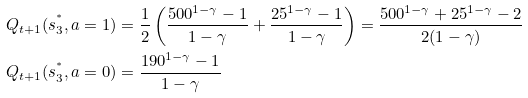<formula> <loc_0><loc_0><loc_500><loc_500>Q _ { t + 1 } ( s _ { 3 } ^ { ^ { * } } , a = 1 ) & = \frac { 1 } { 2 } \left ( \frac { 5 0 0 ^ { 1 - \gamma } - 1 } { 1 - \gamma } + \frac { 2 5 ^ { 1 - \gamma } - 1 } { 1 - \gamma } \right ) = \frac { 5 0 0 ^ { 1 - \gamma } + 2 5 ^ { 1 - \gamma } - 2 } { 2 ( 1 - \gamma ) } \\ Q _ { t + 1 } ( s _ { 3 } ^ { ^ { * } } , a = 0 ) & = \frac { 1 9 0 ^ { 1 - \gamma } - 1 } { 1 - \gamma }</formula> 